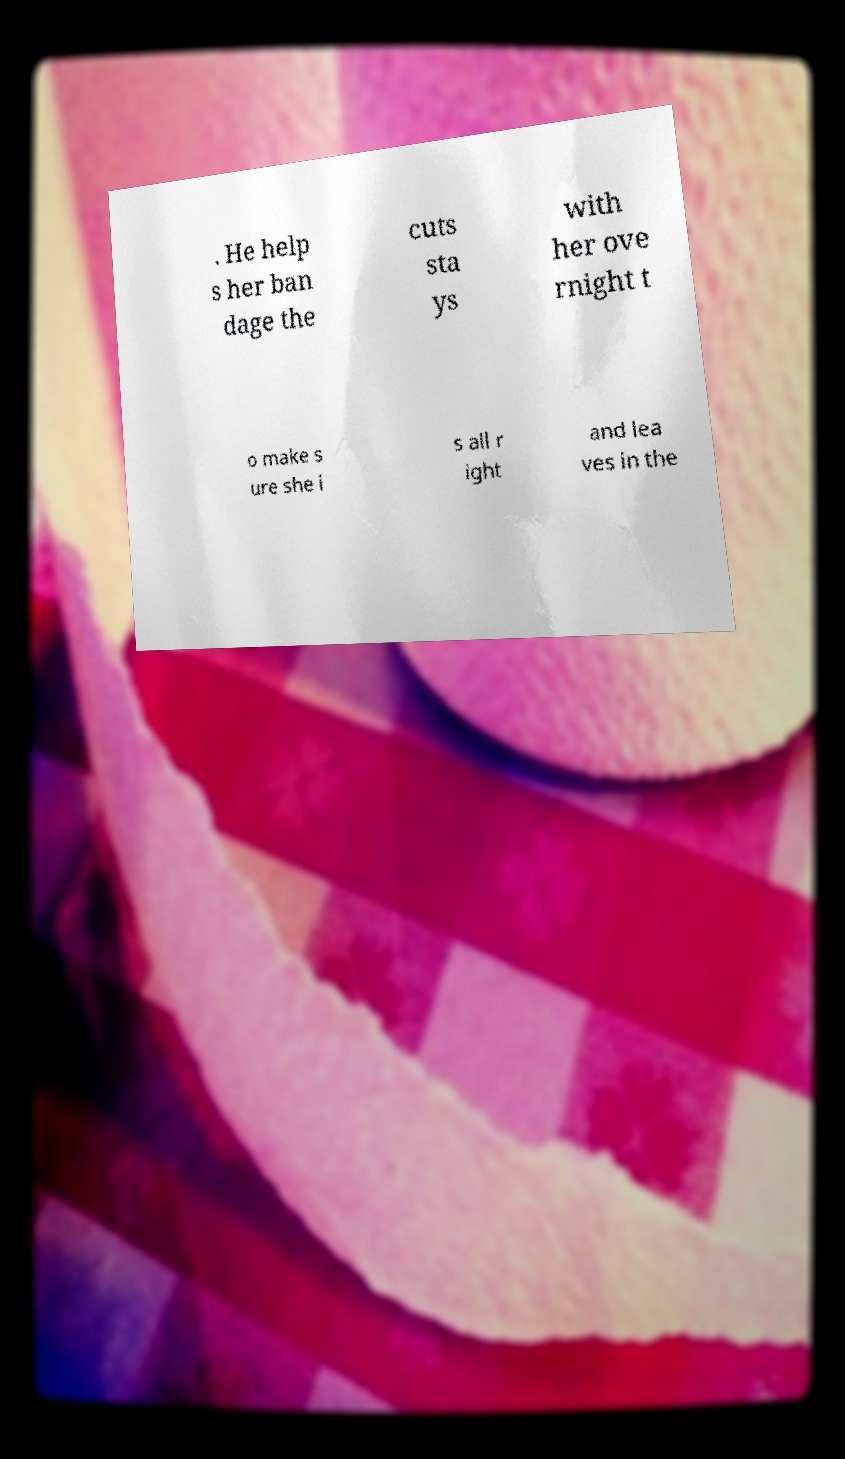Can you accurately transcribe the text from the provided image for me? . He help s her ban dage the cuts sta ys with her ove rnight t o make s ure she i s all r ight and lea ves in the 